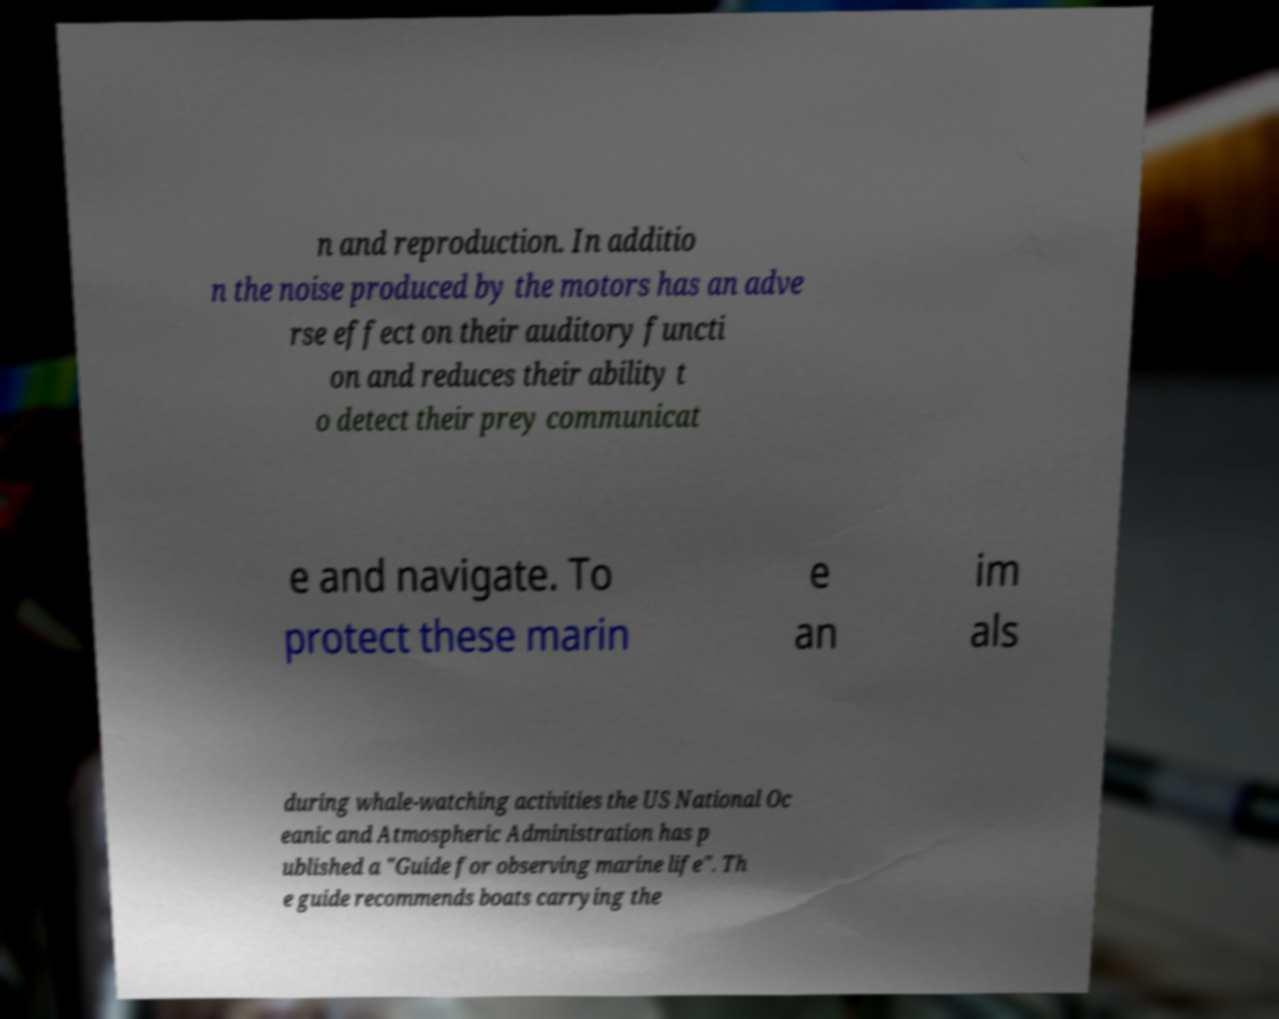Please identify and transcribe the text found in this image. n and reproduction. In additio n the noise produced by the motors has an adve rse effect on their auditory functi on and reduces their ability t o detect their prey communicat e and navigate. To protect these marin e an im als during whale-watching activities the US National Oc eanic and Atmospheric Administration has p ublished a "Guide for observing marine life". Th e guide recommends boats carrying the 